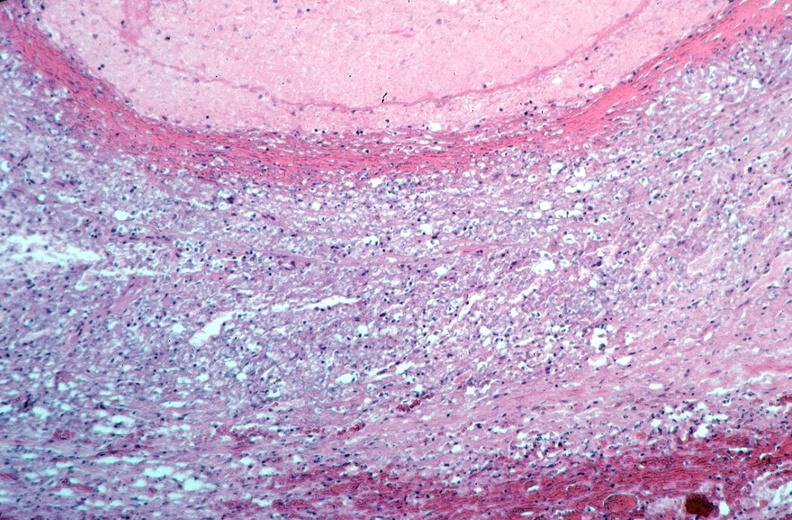s cardiovascular present?
Answer the question using a single word or phrase. Yes 